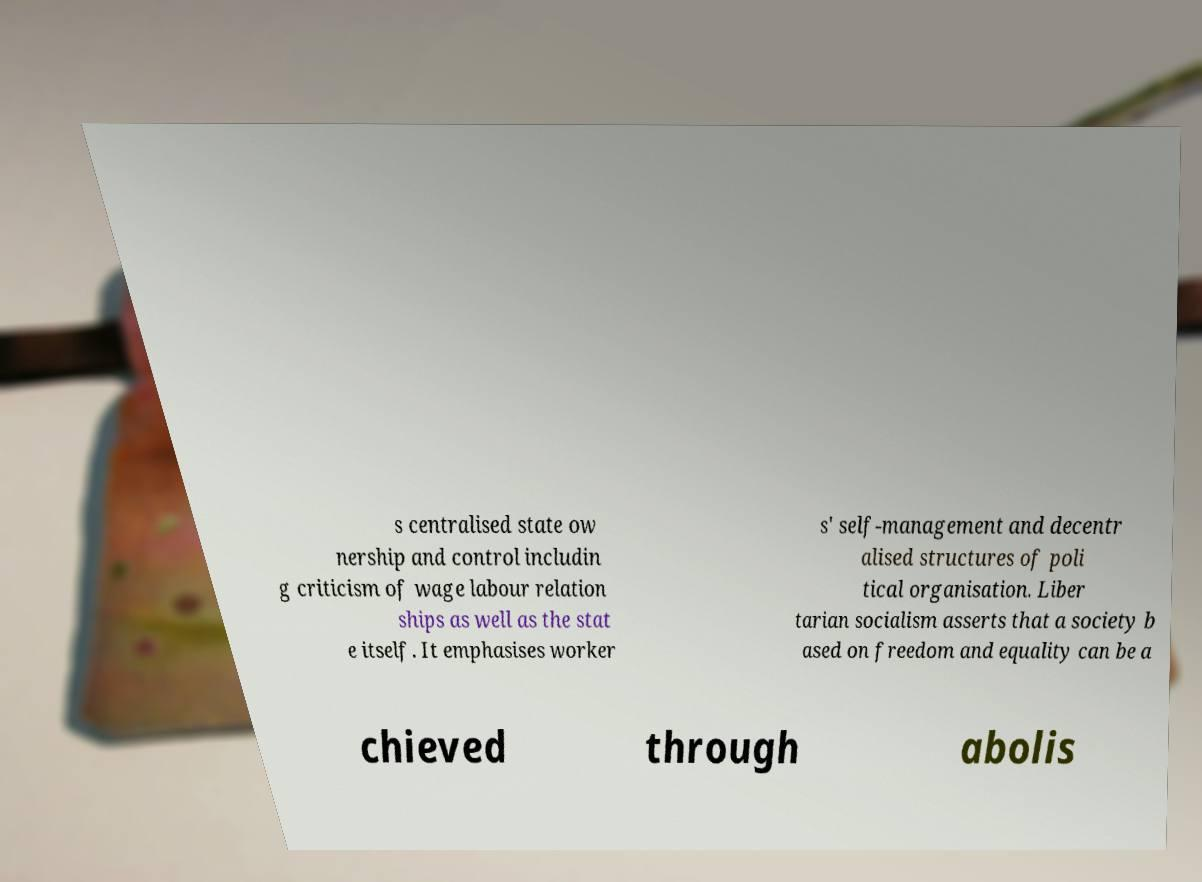Can you accurately transcribe the text from the provided image for me? s centralised state ow nership and control includin g criticism of wage labour relation ships as well as the stat e itself. It emphasises worker s' self-management and decentr alised structures of poli tical organisation. Liber tarian socialism asserts that a society b ased on freedom and equality can be a chieved through abolis 